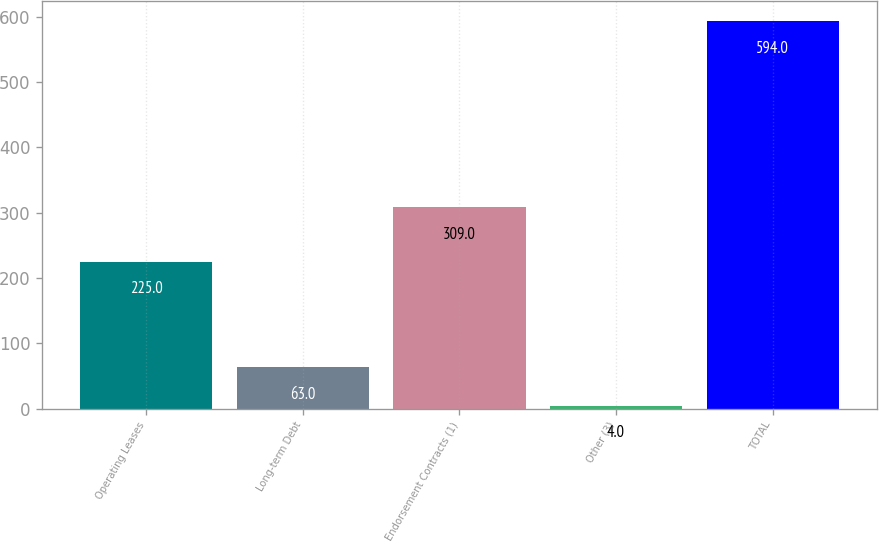Convert chart to OTSL. <chart><loc_0><loc_0><loc_500><loc_500><bar_chart><fcel>Operating Leases<fcel>Long-term Debt<fcel>Endorsement Contracts (1)<fcel>Other (3)<fcel>TOTAL<nl><fcel>225<fcel>63<fcel>309<fcel>4<fcel>594<nl></chart> 